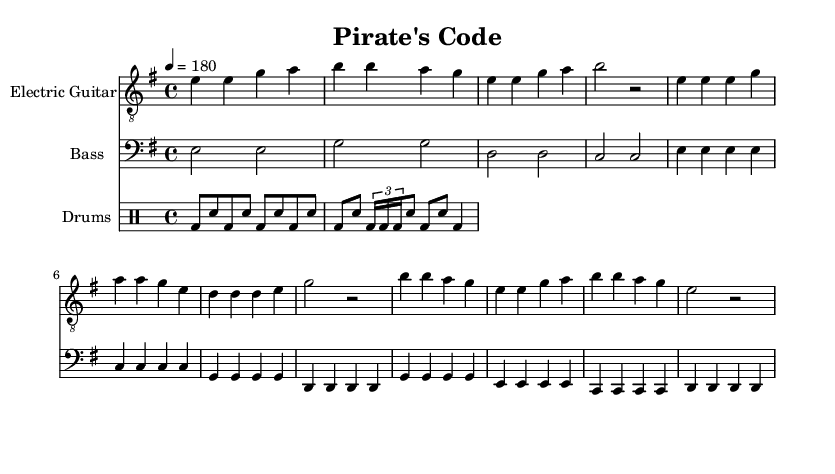What is the key signature of this music? The key signature is E minor, which has one sharp (F#). It can be confirmed by looking at the key signature indicated at the beginning of the sheet music.
Answer: E minor What is the time signature of the piece? The time signature is 4/4, as indicated in the time signature section at the beginning of the music sheet. This means there are four beats in each measure, and the quarter note gets one beat.
Answer: 4/4 What is the tempo marking for this music? The tempo marking is 180 beats per minute. This is indicated in the tempo section in the global settings at the start of the score, stating to play at 4 = 180.
Answer: 180 How many measures are in the intro section for the electric guitar? The intro section consists of 8 measures. By counting the number of measure bars shown in the electric guitar part for the intro, we can see that it contains 8 individual measures.
Answer: 8 What is the minimum number of instruments used in this piece? There are three instruments used: electric guitar, bass, and drums. The score explicitly shows three distinct staves, each labeled for one of the instruments.
Answer: Three Which section of the song features a fill in the drum part? The drum part features a fill in the section after the basic pattern in the drumming part. It uses tuplets, indicating the complexity of the pattern is greater than the basic beat structure.
Answer: Fill What kind of musical structure does this punk rock song represent? The structure of the song aligns with typical punk rock conventions, indicating a clear verse-chorus format which can be inferred from the abbreviated sections labeled "Verse" and "Chorus."
Answer: Verse-Chorus 